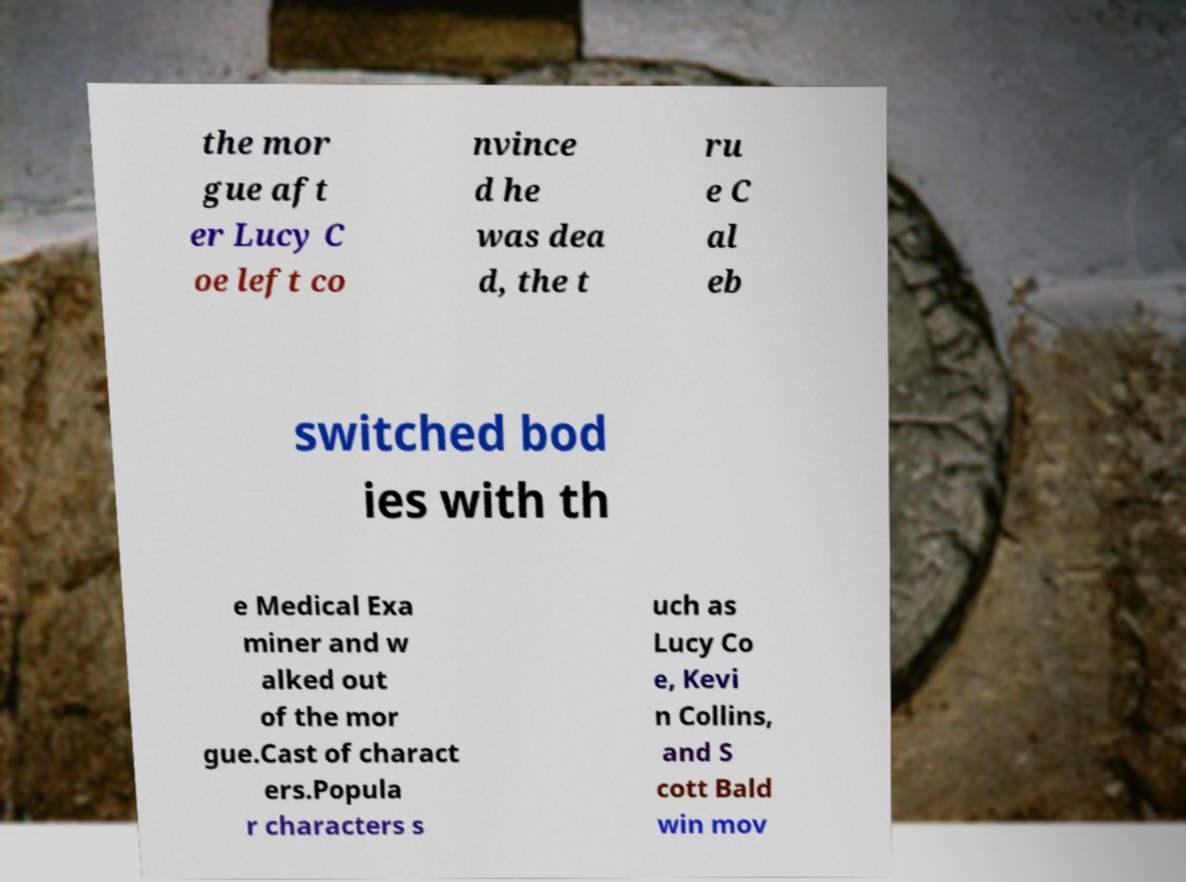Can you read and provide the text displayed in the image?This photo seems to have some interesting text. Can you extract and type it out for me? the mor gue aft er Lucy C oe left co nvince d he was dea d, the t ru e C al eb switched bod ies with th e Medical Exa miner and w alked out of the mor gue.Cast of charact ers.Popula r characters s uch as Lucy Co e, Kevi n Collins, and S cott Bald win mov 